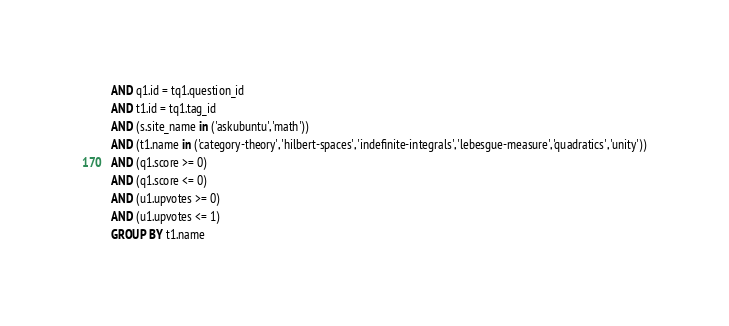Convert code to text. <code><loc_0><loc_0><loc_500><loc_500><_SQL_>AND q1.id = tq1.question_id
AND t1.id = tq1.tag_id
AND (s.site_name in ('askubuntu','math'))
AND (t1.name in ('category-theory','hilbert-spaces','indefinite-integrals','lebesgue-measure','quadratics','unity'))
AND (q1.score >= 0)
AND (q1.score <= 0)
AND (u1.upvotes >= 0)
AND (u1.upvotes <= 1)
GROUP BY t1.name</code> 